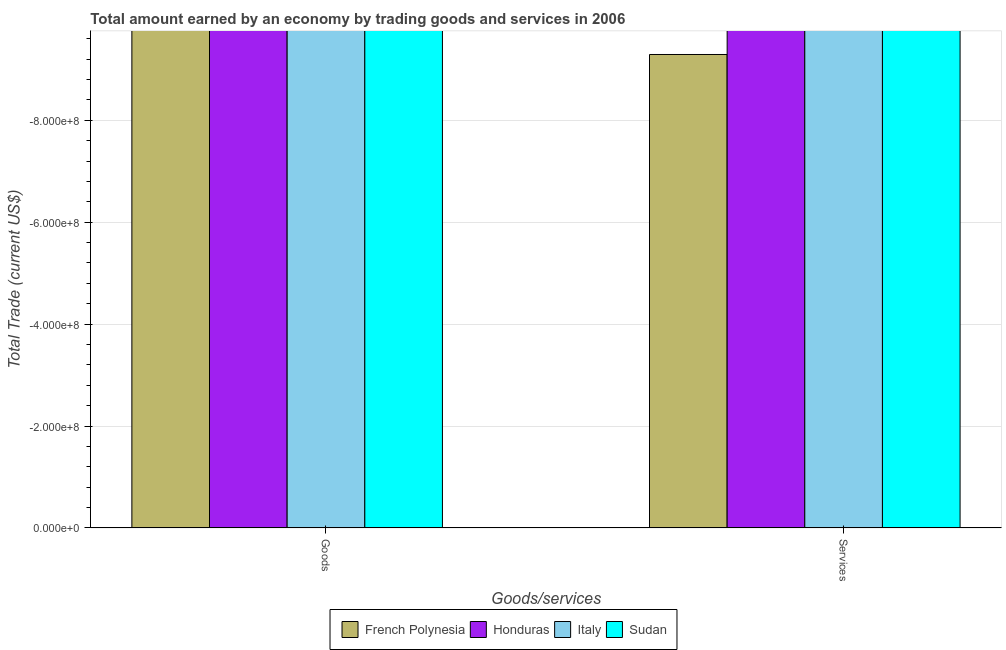How many different coloured bars are there?
Provide a succinct answer. 0. How many bars are there on the 1st tick from the left?
Make the answer very short. 0. How many bars are there on the 1st tick from the right?
Provide a succinct answer. 0. What is the label of the 2nd group of bars from the left?
Your answer should be very brief. Services. What is the amount earned by trading services in French Polynesia?
Your answer should be very brief. 0. What is the total amount earned by trading goods in the graph?
Make the answer very short. 0. What is the average amount earned by trading services per country?
Ensure brevity in your answer.  0. How many bars are there?
Ensure brevity in your answer.  0. Are all the bars in the graph horizontal?
Offer a very short reply. No. Does the graph contain any zero values?
Give a very brief answer. Yes. Where does the legend appear in the graph?
Your response must be concise. Bottom center. How are the legend labels stacked?
Provide a short and direct response. Horizontal. What is the title of the graph?
Your response must be concise. Total amount earned by an economy by trading goods and services in 2006. Does "Least developed countries" appear as one of the legend labels in the graph?
Your answer should be compact. No. What is the label or title of the X-axis?
Keep it short and to the point. Goods/services. What is the label or title of the Y-axis?
Your answer should be compact. Total Trade (current US$). What is the Total Trade (current US$) in French Polynesia in Goods?
Your answer should be compact. 0. What is the Total Trade (current US$) in Honduras in Goods?
Ensure brevity in your answer.  0. What is the Total Trade (current US$) of Honduras in Services?
Ensure brevity in your answer.  0. What is the Total Trade (current US$) of Sudan in Services?
Your answer should be very brief. 0. What is the total Total Trade (current US$) of Sudan in the graph?
Offer a terse response. 0. What is the average Total Trade (current US$) of French Polynesia per Goods/services?
Your response must be concise. 0. What is the average Total Trade (current US$) in Sudan per Goods/services?
Your response must be concise. 0. 